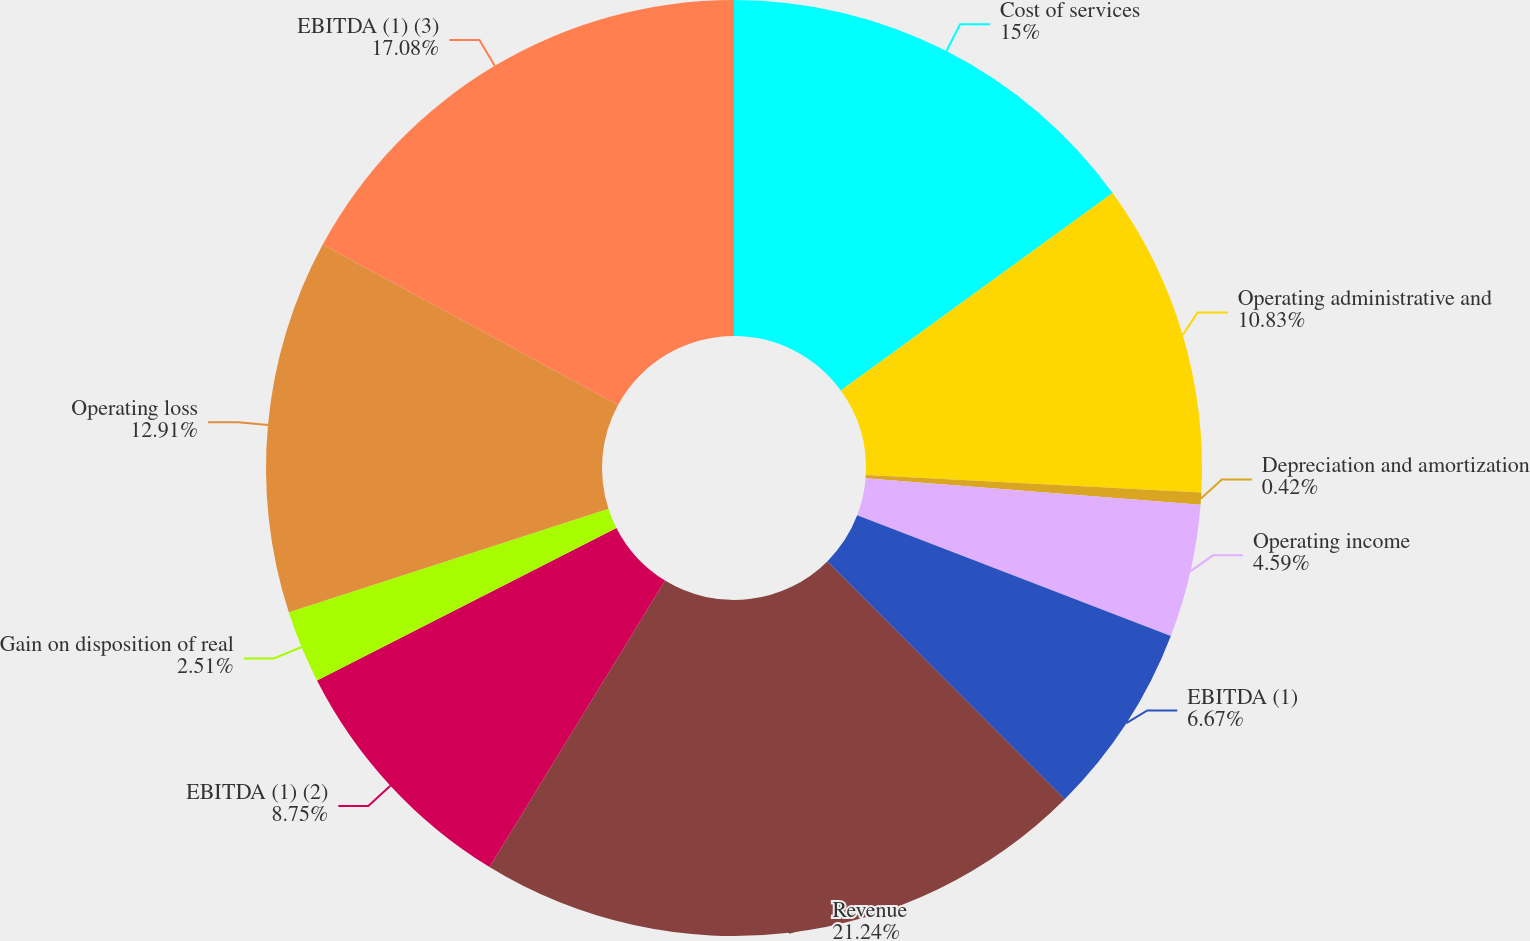<chart> <loc_0><loc_0><loc_500><loc_500><pie_chart><fcel>Cost of services<fcel>Operating administrative and<fcel>Depreciation and amortization<fcel>Operating income<fcel>EBITDA (1)<fcel>Revenue<fcel>EBITDA (1) (2)<fcel>Gain on disposition of real<fcel>Operating loss<fcel>EBITDA (1) (3)<nl><fcel>15.0%<fcel>10.83%<fcel>0.42%<fcel>4.59%<fcel>6.67%<fcel>21.24%<fcel>8.75%<fcel>2.51%<fcel>12.91%<fcel>17.08%<nl></chart> 